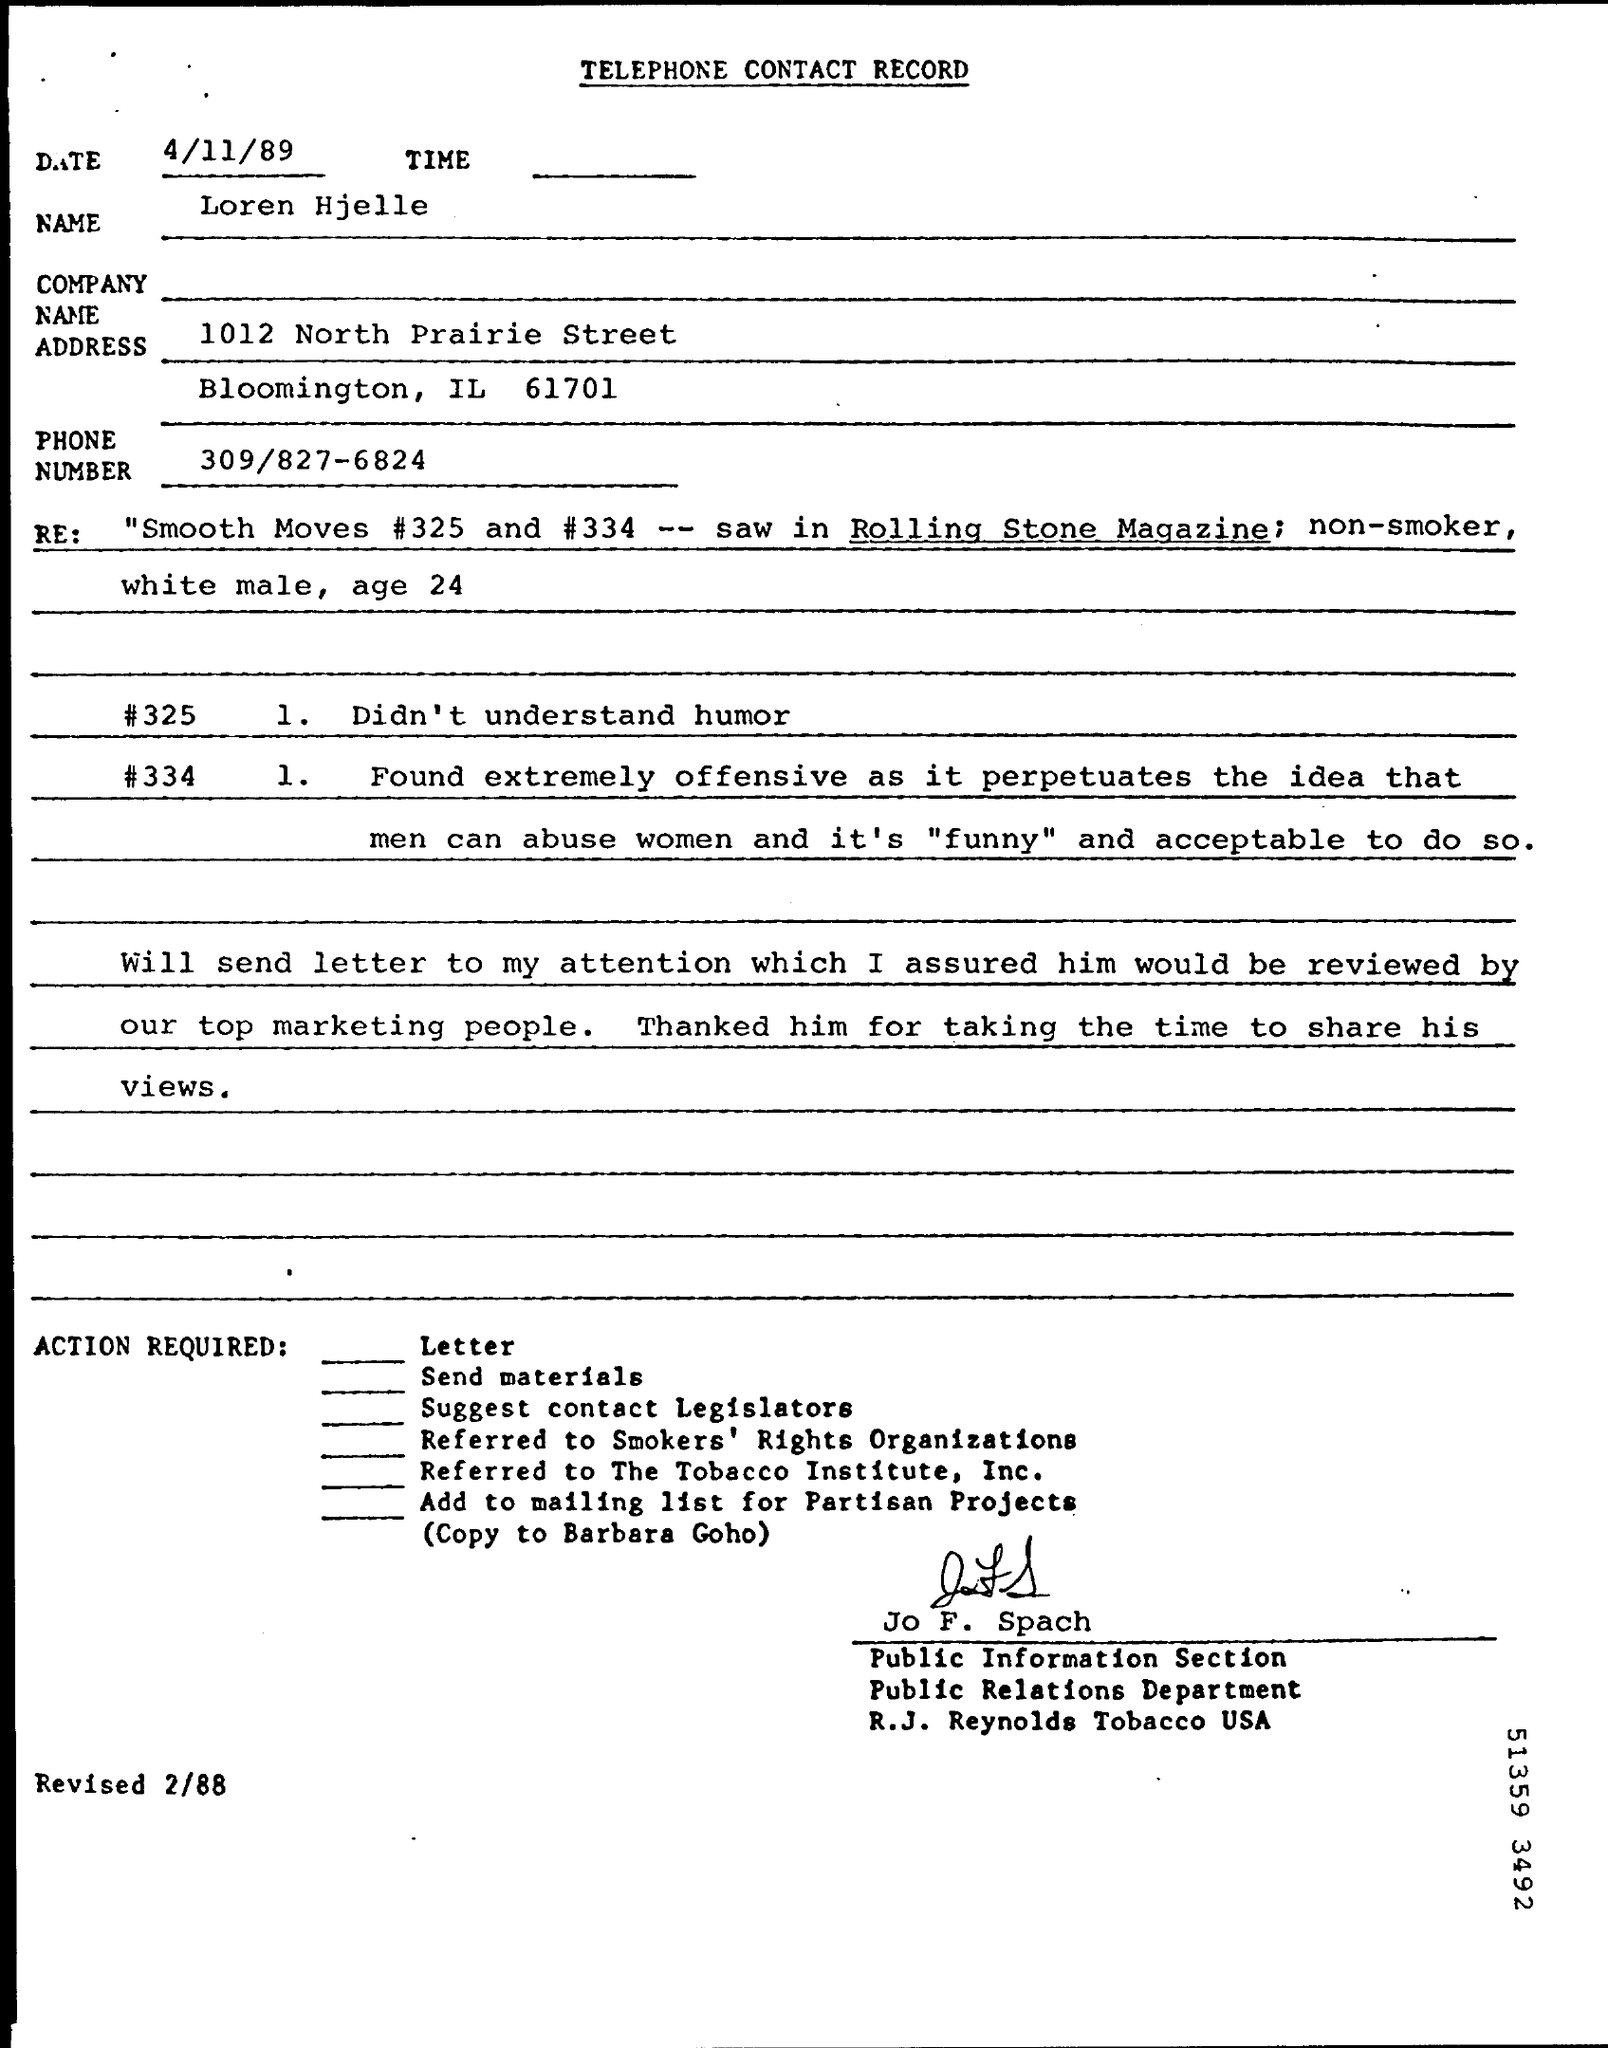Can you provide more details on the actions suggested at the end of this contact record? The document suggests several follow-up actions including sending materials, proposing that the person contact legislators, referring the matter to the Tobacco Institute and Smokers' Rights Organizations, and adding the person to a mailing list for Partisan Projects. 